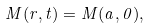Convert formula to latex. <formula><loc_0><loc_0><loc_500><loc_500>M ( r , t ) = M ( a , 0 ) ,</formula> 